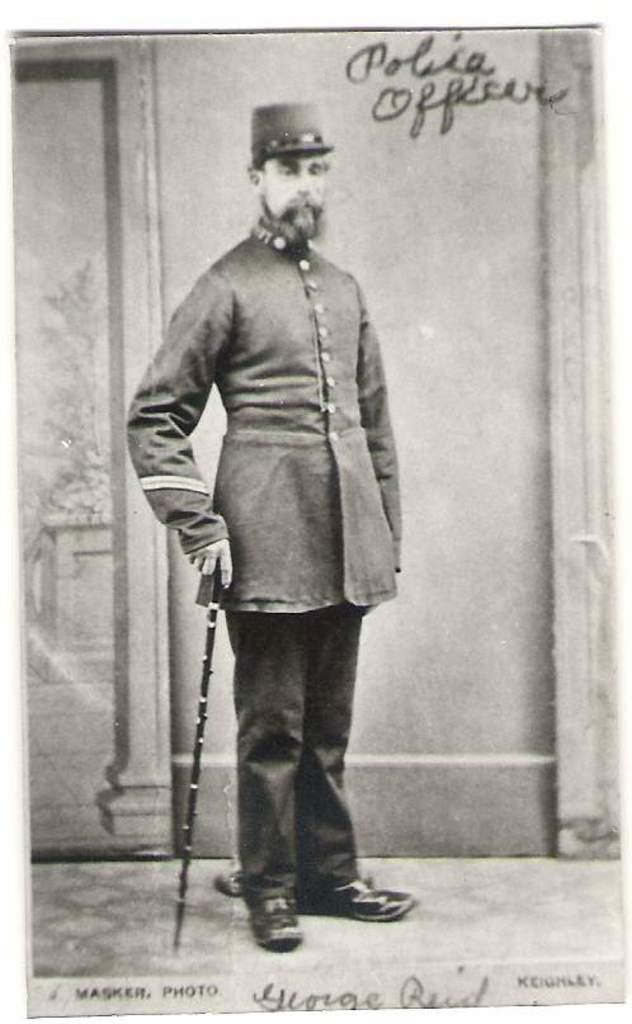Provide a one-sentence caption for the provided image. old black and white photo of man in uniform with polica officer written at top and name george reid at bottom. 